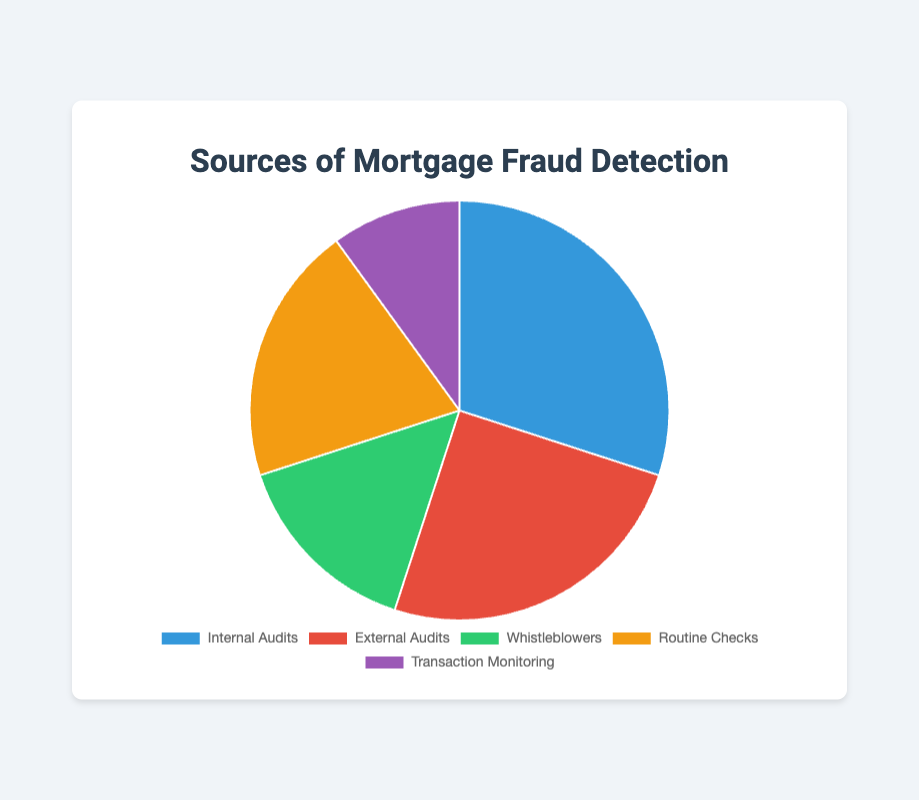Which source has the highest percentage of mortgage fraud detection? Looking at the pie chart, the segment for "Internal Audits" is the largest.
Answer: Internal Audits Which source has the lowest percentage of mortgage fraud detection? The segment for "Transaction Monitoring" is the smallest in the pie chart.
Answer: Transaction Monitoring What's the total percentage of mortgage fraud detected through audits (internal and external)? Sum the percentages of Internal Audits and External Audits: 30% + 25%
Answer: 55% How much more fraud is detected by routine checks compared to whistleblowers? Subtract the percentage of Whistleblowers from Routine Checks: 20% - 15%
Answer: 5% If Internal Audits detect 30% of fraud, what percentage of fraud is detected by the remaining sources combined? Sum the percentages of the other sources: 25% (External Audits) + 15% (Whistleblowers) + 20% (Routine Checks) + 10% (Transaction Monitoring) = 70%
Answer: 70% Which source combination detects more fraud: Internal Audits and Routine Checks, or External Audits and Whistleblowers? Sum the percentages for each combination: Internal Audits and Routine Checks: 30% + 20% = 50%, External Audits and Whistleblowers: 25% + 15% = 40%
Answer: Internal Audits and Routine Checks By how much does the percentage detected by External Audits exceed the percentage detected by Transaction Monitoring? Subtract the percentage of Transaction Monitoring from External Audits: 25% - 10%
Answer: 15% What is the average percentage of fraud detection across all sources? Sum all percentages and divide by the number of sources: (30% + 25% + 15% + 20% + 10%) / 5 = 100/5
Answer: 20% What can you infer about the relative effectiveness of audits (both internal and external) compared to non-audit sources (whistleblowers, routine checks, transaction monitoring)? Calculate total audit percentage and non-audit percentage: Audits: 30% + 25% = 55%, Non-Audits: 15% + 20% + 10% = 45%. Audits are more effective by 10%.
Answer: Audits are more effective 